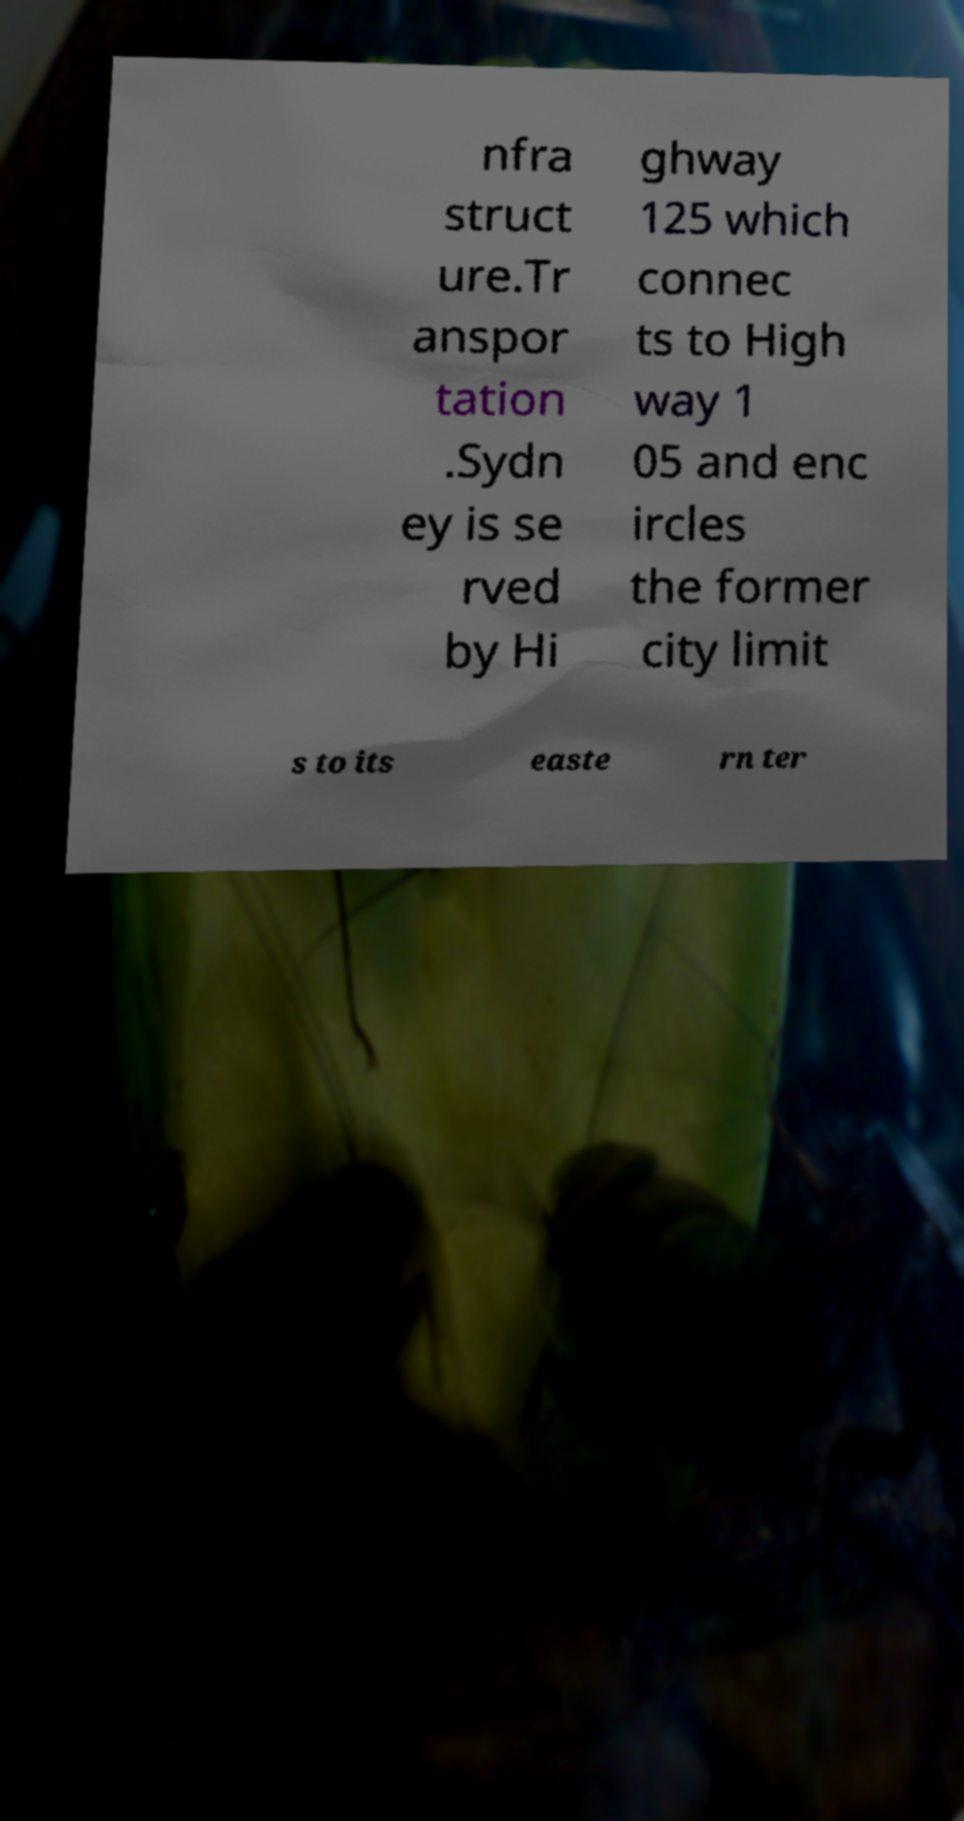For documentation purposes, I need the text within this image transcribed. Could you provide that? nfra struct ure.Tr anspor tation .Sydn ey is se rved by Hi ghway 125 which connec ts to High way 1 05 and enc ircles the former city limit s to its easte rn ter 